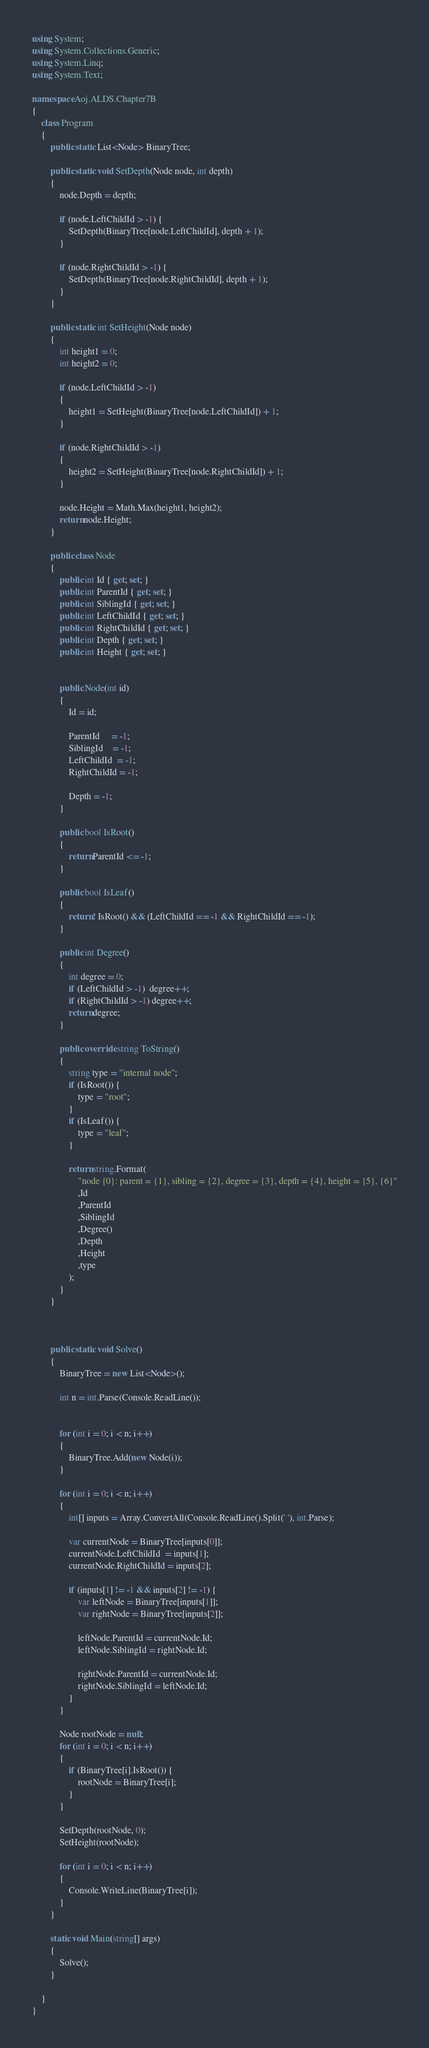Convert code to text. <code><loc_0><loc_0><loc_500><loc_500><_C#_>using System;
using System.Collections.Generic;
using System.Linq;
using System.Text;
 
namespace Aoj.ALDS.Chapter7B
{
    class Program
    {
        public static List<Node> BinaryTree;
 
        public static void SetDepth(Node node, int depth)
        {
            node.Depth = depth;
          
            if (node.LeftChildId > -1) {
                SetDepth(BinaryTree[node.LeftChildId], depth + 1);
            }
 
            if (node.RightChildId > -1) {
                SetDepth(BinaryTree[node.RightChildId], depth + 1);
            }
        }
 
        public static int SetHeight(Node node)
        {
            int height1 = 0;
            int height2 = 0;
 
            if (node.LeftChildId > -1)
            {
                height1 = SetHeight(BinaryTree[node.LeftChildId]) + 1;
            }
 
            if (node.RightChildId > -1)
            {
                height2 = SetHeight(BinaryTree[node.RightChildId]) + 1;
            }
 
            node.Height = Math.Max(height1, height2);
            return node.Height;
        }
 
        public class Node
        {
            public int Id { get; set; } 
            public int ParentId { get; set; }
            public int SiblingId { get; set; }
            public int LeftChildId { get; set; }
            public int RightChildId { get; set; }
            public int Depth { get; set; }
            public int Height { get; set; }
 
 
            public Node(int id)
            {
                Id = id;
 
                ParentId     = -1;
                SiblingId    = -1;
                LeftChildId  = -1;
                RightChildId = -1;
 
                Depth = -1;
            }
 
            public bool IsRoot()
            {
                return ParentId <= -1;
            }
 
            public bool IsLeaf()
            {
                return ! IsRoot() && (LeftChildId == -1 && RightChildId == -1);
            }
 
            public int Degree()
            {
                int degree = 0;
                if (LeftChildId > -1)  degree++;
                if (RightChildId > -1) degree++;
                return degree;
            }
 
            public override string ToString()
            {
                string type = "internal node";
                if (IsRoot()) {
                    type = "root";
                }
                if (IsLeaf()) {
                    type = "leaf";
                }
 
                return string.Format(
                    "node {0}: parent = {1}, sibling = {2}, degree = {3}, depth = {4}, height = {5}, {6}"
                    ,Id
                    ,ParentId
                    ,SiblingId
                    ,Degree()
                    ,Depth
                    ,Height
                    ,type
                );             
            }
        }
 
 
 
        public static void Solve()
        {
            BinaryTree = new List<Node>();
 
            int n = int.Parse(Console.ReadLine());
 
 
            for (int i = 0; i < n; i++)
            {
                BinaryTree.Add(new Node(i));
            }
 
            for (int i = 0; i < n; i++)
            {
                int[] inputs = Array.ConvertAll(Console.ReadLine().Split(' '), int.Parse);
 
                var currentNode = BinaryTree[inputs[0]];
                currentNode.LeftChildId  = inputs[1];
                currentNode.RightChildId = inputs[2];
 
                if (inputs[1] != -1 && inputs[2] != -1) {
                    var leftNode = BinaryTree[inputs[1]];
                    var rightNode = BinaryTree[inputs[2]];
 
                    leftNode.ParentId = currentNode.Id;
                    leftNode.SiblingId = rightNode.Id;
 
                    rightNode.ParentId = currentNode.Id;
                    rightNode.SiblingId = leftNode.Id;
                }
            }
 
            Node rootNode = null;
            for (int i = 0; i < n; i++)
            {
                if (BinaryTree[i].IsRoot()) {
                    rootNode = BinaryTree[i];
                }
            }
 
            SetDepth(rootNode, 0);
            SetHeight(rootNode);
 
            for (int i = 0; i < n; i++)
            {
                Console.WriteLine(BinaryTree[i]);
            }
        }
 
        static void Main(string[] args)
        {
            Solve();
        }
 
    }
}</code> 